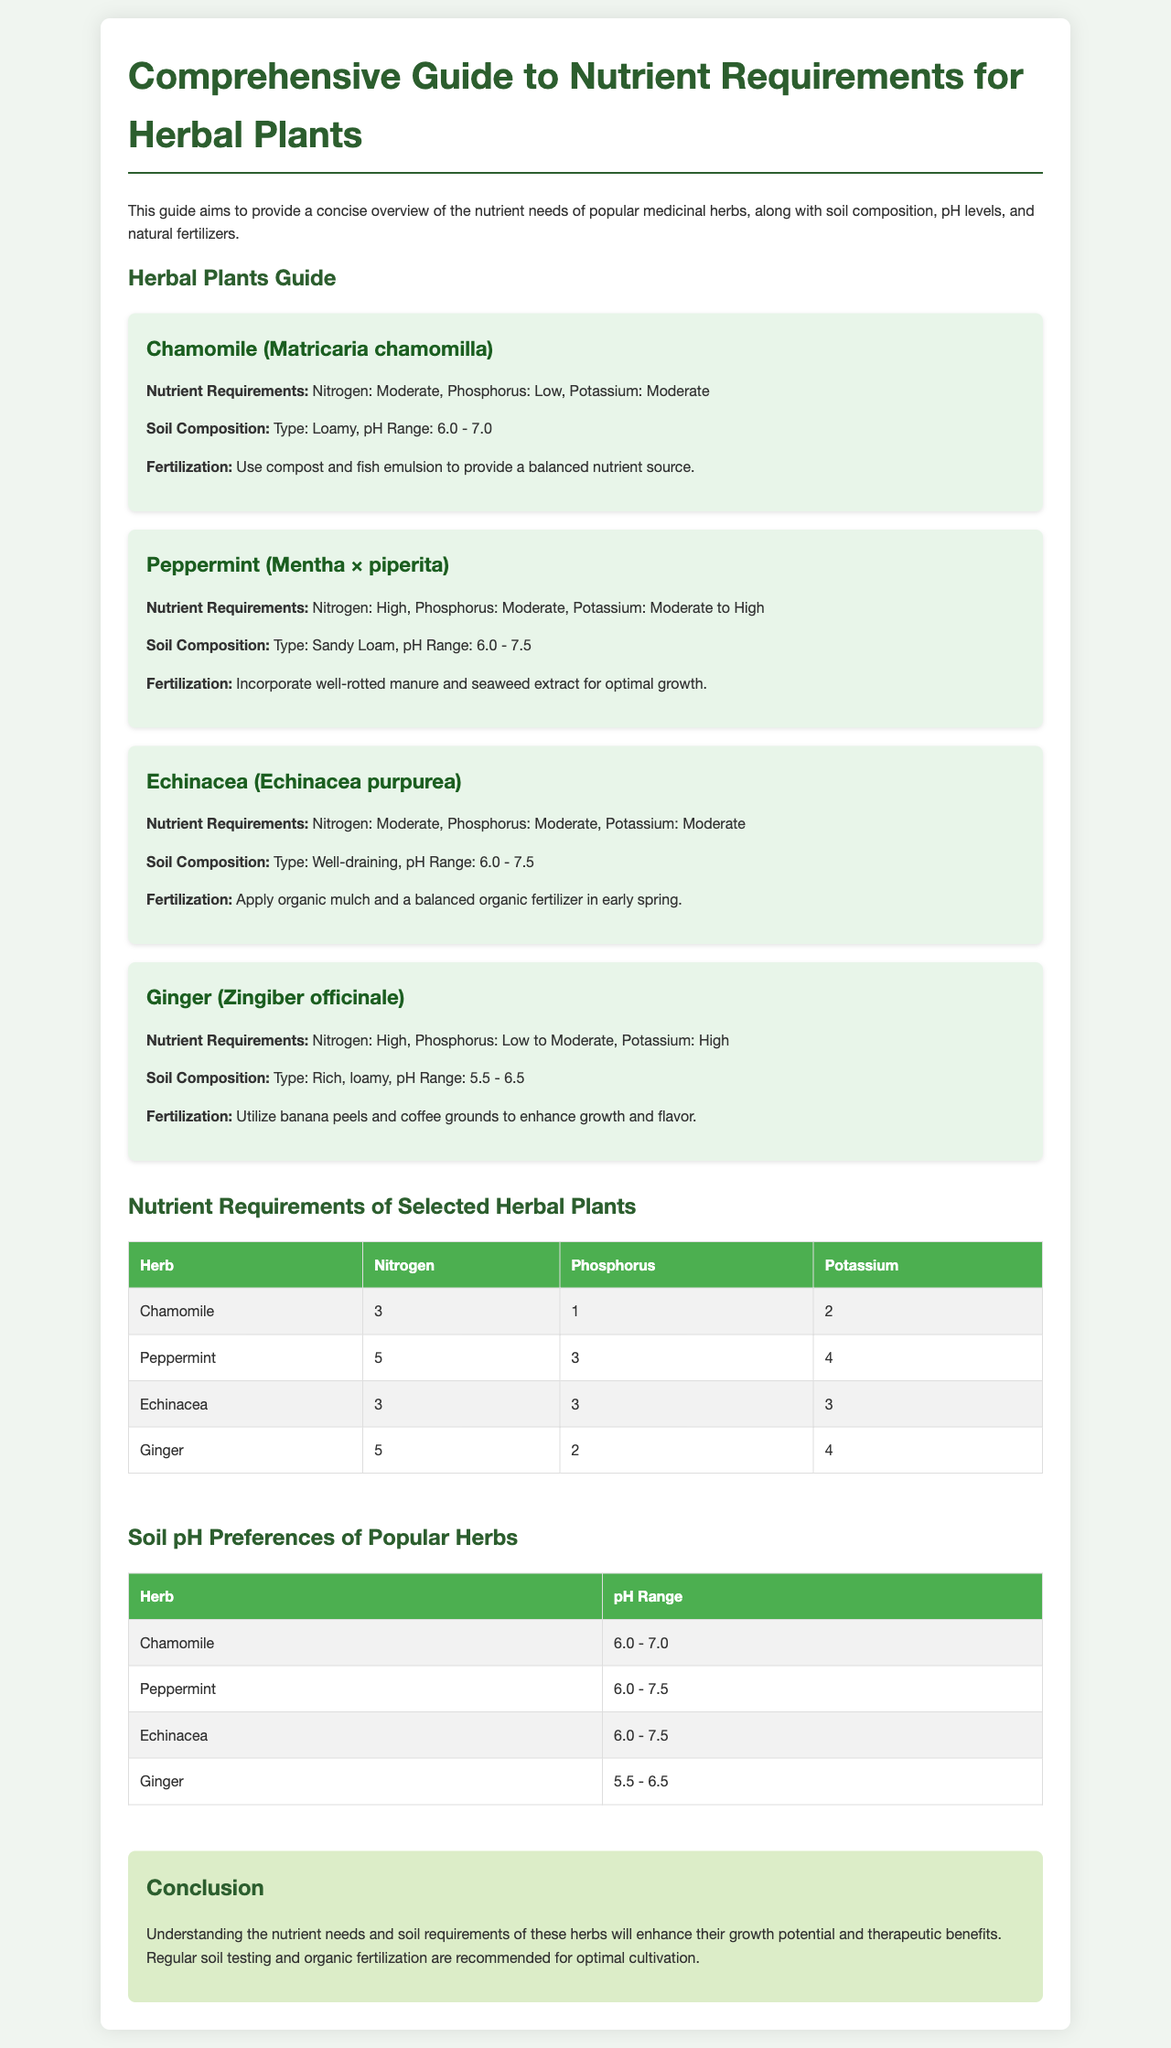What is the nitrogen requirement for Chamomile? The nitrogen requirement for Chamomile is specified as moderate.
Answer: Moderate What is the pH range for Ginger? The pH range for Ginger is listed in the soil pH preferences table.
Answer: 5.5 - 6.5 Which natural fertilizers are suggested for Echinacea? The document states that organic mulch and a balanced organic fertilizer should be applied in early spring.
Answer: Organic mulch and a balanced organic fertilizer How does Peppermint's potassium requirement compare to Echinacea's? By comparing the nutrient requirement details provided for both herbs, Peppermint has a higher potassium requirement than Echinacea.
Answer: Higher Which herb has the highest phosphorus requirement? Looking at the nutrient requirements chart, Peppermint has the highest phosphorus requirement among the listed herbs.
Answer: Peppermint What type of soil is recommended for Chamomile? The document specifies that Chamomile prefers loamy soil composition.
Answer: Loamy What is the conclusion regarding fertilization for the herbs? The conclusion advises regular soil testing and organic fertilization for optimal cultivation of the herbs.
Answer: Regular soil testing and organic fertilization Which herb has moderate nitrogen and phosphorus needs? The details show that Echinacea has both moderate nitrogen and phosphorus needs.
Answer: Echinacea 